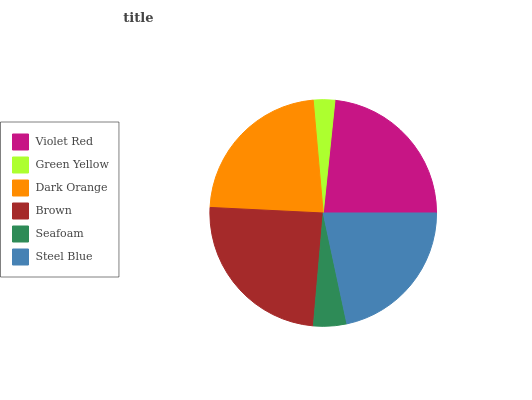Is Green Yellow the minimum?
Answer yes or no. Yes. Is Brown the maximum?
Answer yes or no. Yes. Is Dark Orange the minimum?
Answer yes or no. No. Is Dark Orange the maximum?
Answer yes or no. No. Is Dark Orange greater than Green Yellow?
Answer yes or no. Yes. Is Green Yellow less than Dark Orange?
Answer yes or no. Yes. Is Green Yellow greater than Dark Orange?
Answer yes or no. No. Is Dark Orange less than Green Yellow?
Answer yes or no. No. Is Dark Orange the high median?
Answer yes or no. Yes. Is Steel Blue the low median?
Answer yes or no. Yes. Is Green Yellow the high median?
Answer yes or no. No. Is Green Yellow the low median?
Answer yes or no. No. 